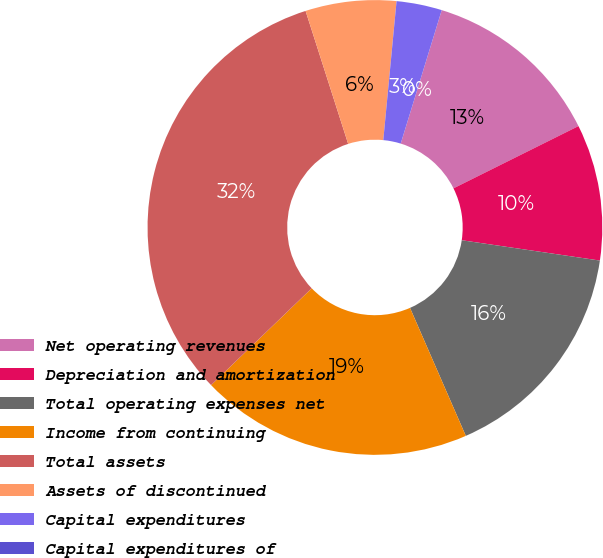Convert chart. <chart><loc_0><loc_0><loc_500><loc_500><pie_chart><fcel>Net operating revenues<fcel>Depreciation and amortization<fcel>Total operating expenses net<fcel>Income from continuing<fcel>Total assets<fcel>Assets of discontinued<fcel>Capital expenditures<fcel>Capital expenditures of<nl><fcel>12.9%<fcel>9.68%<fcel>16.13%<fcel>19.35%<fcel>32.26%<fcel>6.45%<fcel>3.23%<fcel>0.0%<nl></chart> 